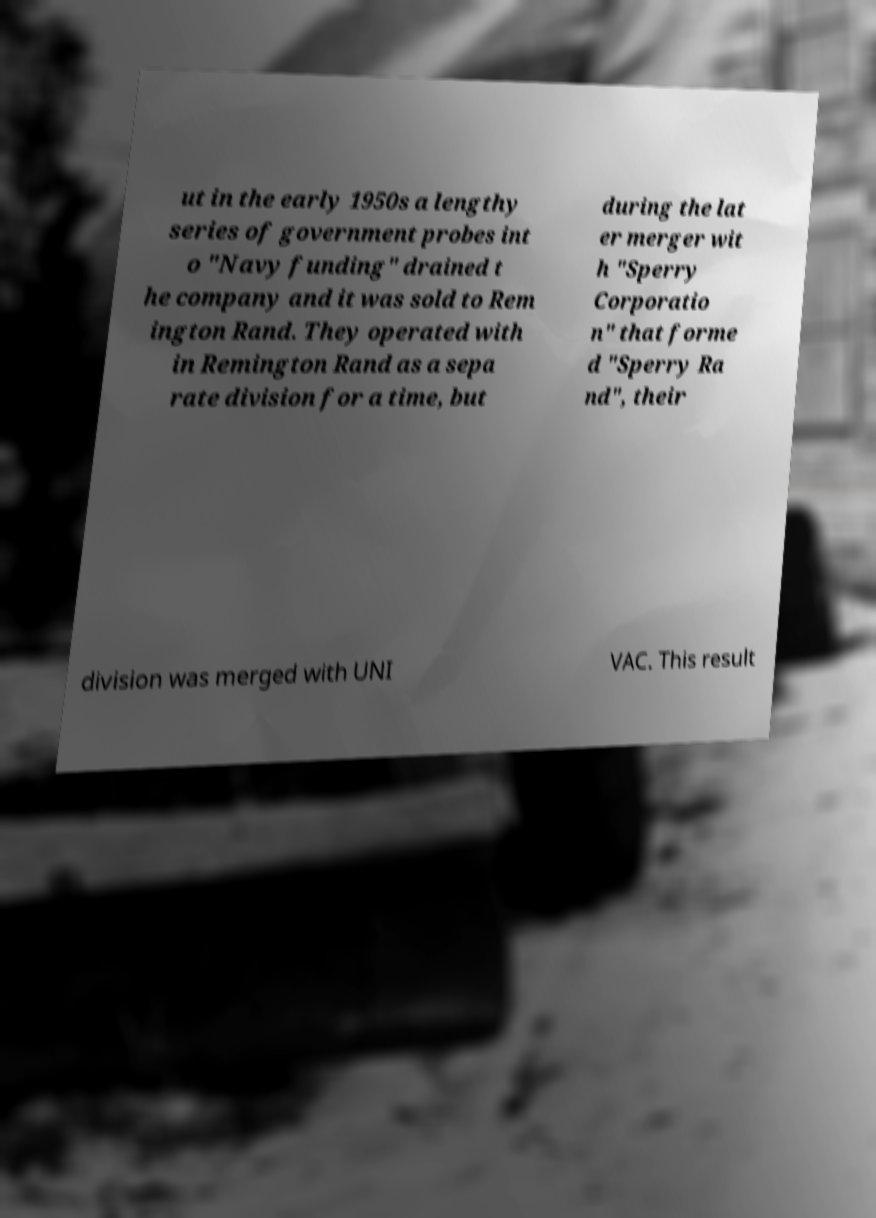Can you read and provide the text displayed in the image?This photo seems to have some interesting text. Can you extract and type it out for me? ut in the early 1950s a lengthy series of government probes int o "Navy funding" drained t he company and it was sold to Rem ington Rand. They operated with in Remington Rand as a sepa rate division for a time, but during the lat er merger wit h "Sperry Corporatio n" that forme d "Sperry Ra nd", their division was merged with UNI VAC. This result 